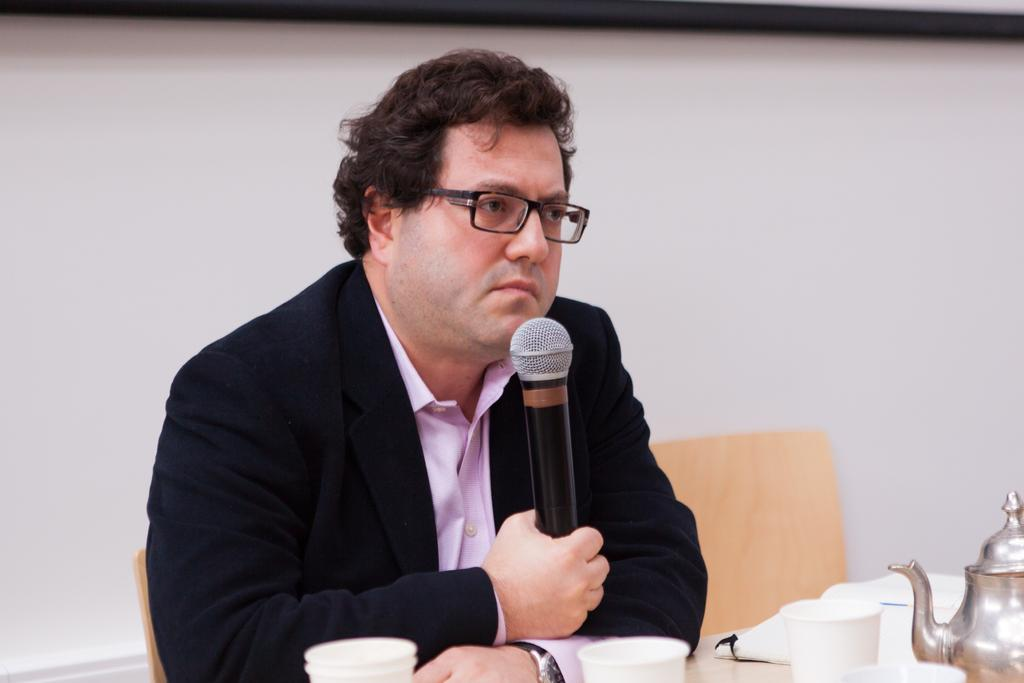Who is present in the image? There is a man in the image. What is the man doing in the image? The man is sitting on a chair and holding a mic. What objects are in front of the man? There are cups and a kettle in front of the man. Can you describe the background of the image? There is a chair and a wall in the background of the image. What type of joke is the man telling in the image? There is no indication in the image that the man is telling a joke, as he is holding a mic and there are cups and a kettle in front of him. --- Facts: 1. There is a car in the image. 2. The car is red. 3. The car has four wheels. 4. There are people in the car. 5. The car is parked on the street. 6. There are trees on the side of the street. Absurd Topics: parrot, sand, umbrella Conversation: What is the main subject of the image? The main subject of the image is a car. Can you describe the car's appearance? The car is red and has four wheels. Who or what is inside the car? There are people in the car. Where is the car located in the image? The car is parked on the street. What can be seen on the side of the street? There are trees on the side of the street. Reasoning: Let's think step by step in order to produce the conversation. We start by identifying the main subject in the image, which is the car. Then, we describe the car's appearance and what is inside it. Next, we provide information about the car's location and the surrounding environment. Each question is designed to elicit a specific detail about the image that is known from the provided facts. Absurd Question/Answer: What type of parrot is sitting on the car's roof in the image? There is no parrot present on the car's roof in the image. --- Facts: 1. There is a dog in the image. 2. The dog is brown. 3. The dog is sitting on a rug. 4. There is a toy in front of the dog. 5. The background of the image is a living room. Absurd Topics: fish, bicycle, mountain Conversation: What is the main subject of the image? The main subject of the image is a dog. Can you describe the dog's appearance? The dog is brown. What is the dog doing in the image? The dog is sitting on a rug. What object is in front of the dog? There is a toy in front of the dog. 